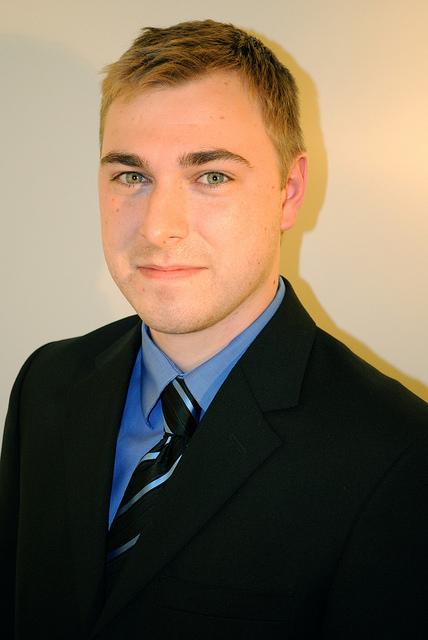What color is this man's shirt?
Answer briefly. Blue. Is this man black?
Answer briefly. No. Is this man happy?
Quick response, please. Yes. Is the man winking?
Quick response, please. No. Can you see the man's shadow on the wall behind him?
Concise answer only. Yes. What ethnicity is the man?
Concise answer only. White. Is he clean-shaven?
Quick response, please. Yes. Does the man's tie have a striped pattern?
Quick response, please. Yes. What color shirt is the man wearing?
Short answer required. Blue. What color is the boys shirt?
Answer briefly. Blue. Is this person wearing a hat?
Concise answer only. No. What color is his hair?
Be succinct. Blonde. What color shirt is this person wearing?
Short answer required. Blue. What is his tie supposed to look like?
Answer briefly. Tie. What color is the shirt?
Write a very short answer. Blue. Is the tie black and blue?
Answer briefly. Yes. 